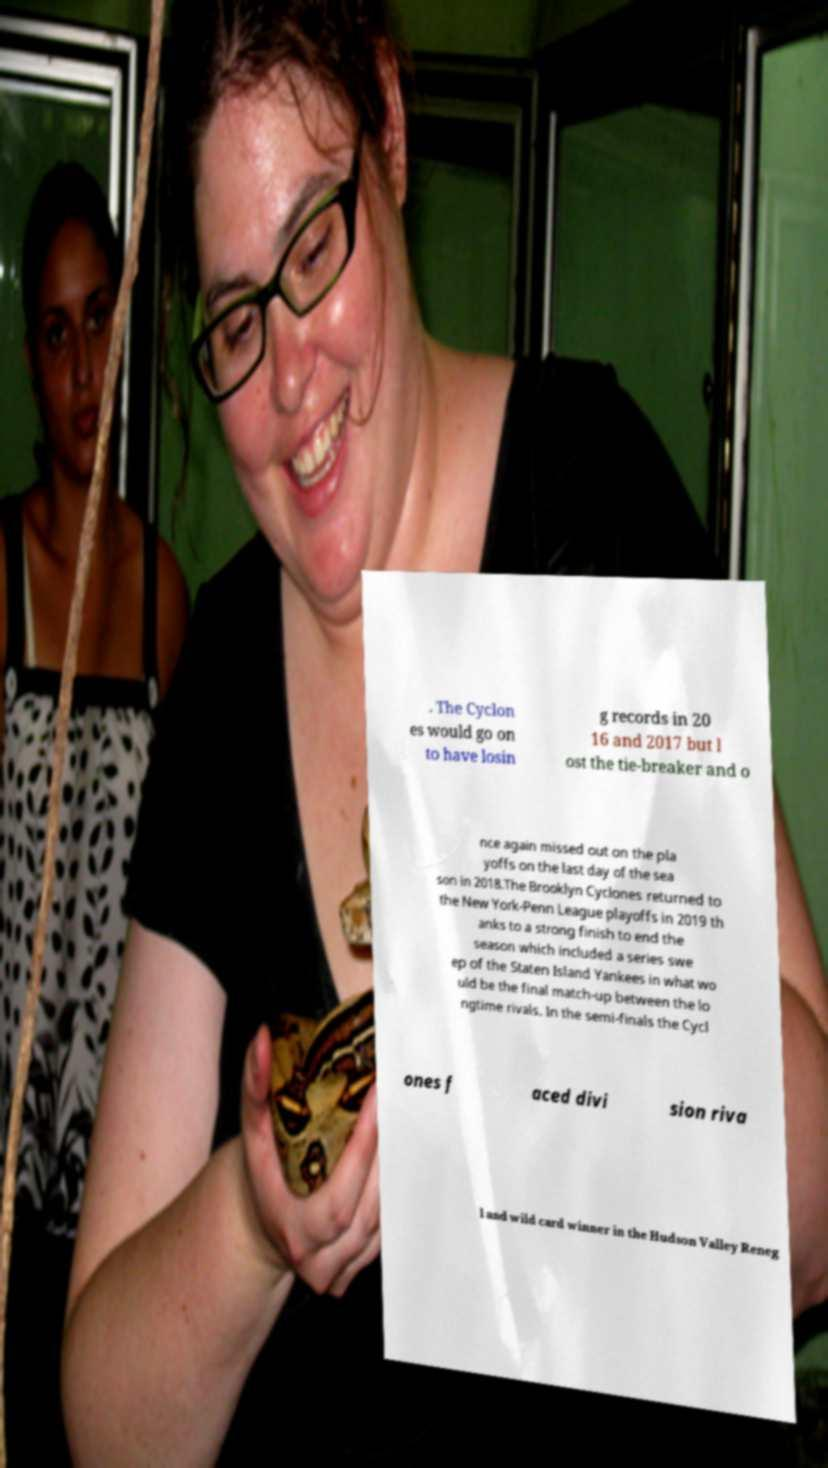Could you extract and type out the text from this image? . The Cyclon es would go on to have losin g records in 20 16 and 2017 but l ost the tie-breaker and o nce again missed out on the pla yoffs on the last day of the sea son in 2018.The Brooklyn Cyclones returned to the New York-Penn League playoffs in 2019 th anks to a strong finish to end the season which included a series swe ep of the Staten Island Yankees in what wo uld be the final match-up between the lo ngtime rivals. In the semi-finals the Cycl ones f aced divi sion riva l and wild card winner in the Hudson Valley Reneg 